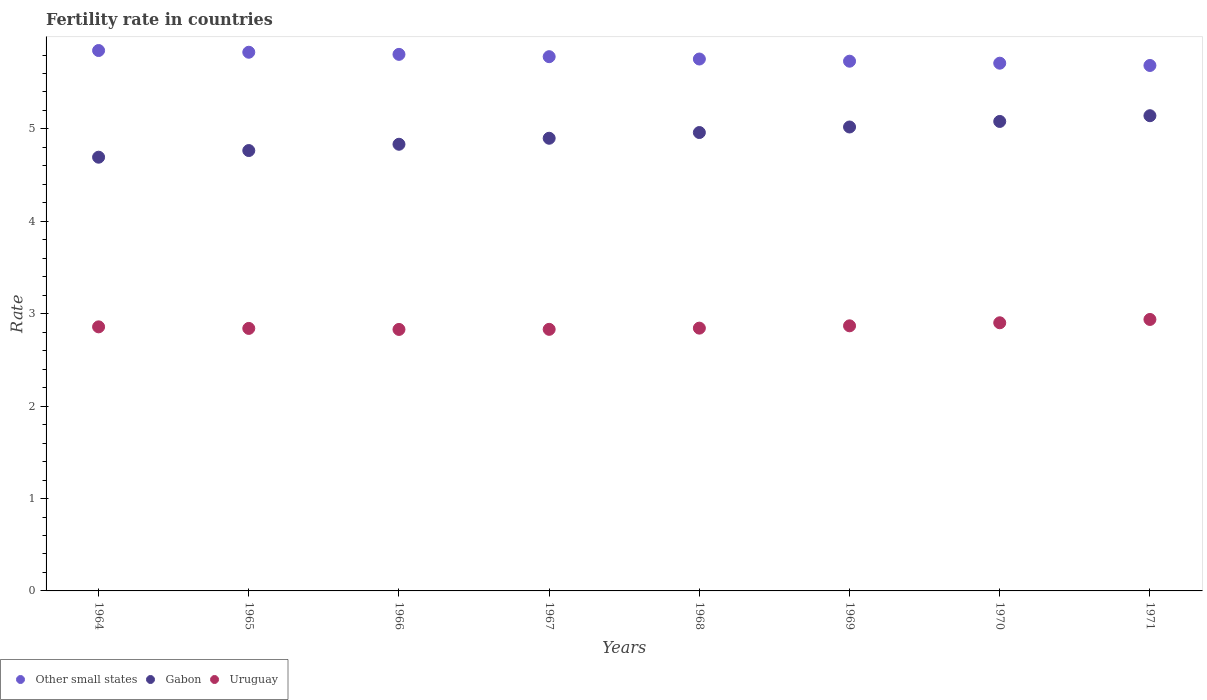What is the fertility rate in Other small states in 1964?
Keep it short and to the point. 5.85. Across all years, what is the maximum fertility rate in Gabon?
Offer a terse response. 5.14. Across all years, what is the minimum fertility rate in Gabon?
Your answer should be compact. 4.69. In which year was the fertility rate in Gabon minimum?
Your response must be concise. 1964. What is the total fertility rate in Gabon in the graph?
Offer a terse response. 39.4. What is the difference between the fertility rate in Uruguay in 1966 and that in 1971?
Keep it short and to the point. -0.11. What is the difference between the fertility rate in Uruguay in 1969 and the fertility rate in Gabon in 1965?
Your answer should be very brief. -1.9. What is the average fertility rate in Other small states per year?
Give a very brief answer. 5.77. In the year 1970, what is the difference between the fertility rate in Uruguay and fertility rate in Other small states?
Make the answer very short. -2.81. In how many years, is the fertility rate in Other small states greater than 4.2?
Your answer should be compact. 8. What is the ratio of the fertility rate in Gabon in 1968 to that in 1970?
Your response must be concise. 0.98. Is the fertility rate in Uruguay in 1964 less than that in 1965?
Give a very brief answer. No. Is the difference between the fertility rate in Uruguay in 1967 and 1969 greater than the difference between the fertility rate in Other small states in 1967 and 1969?
Your answer should be compact. No. What is the difference between the highest and the second highest fertility rate in Other small states?
Your response must be concise. 0.02. What is the difference between the highest and the lowest fertility rate in Gabon?
Offer a terse response. 0.45. Is it the case that in every year, the sum of the fertility rate in Gabon and fertility rate in Uruguay  is greater than the fertility rate in Other small states?
Keep it short and to the point. Yes. Does the fertility rate in Other small states monotonically increase over the years?
Keep it short and to the point. No. Is the fertility rate in Uruguay strictly greater than the fertility rate in Other small states over the years?
Give a very brief answer. No. Is the fertility rate in Other small states strictly less than the fertility rate in Uruguay over the years?
Provide a short and direct response. No. How many years are there in the graph?
Give a very brief answer. 8. Does the graph contain any zero values?
Your answer should be very brief. No. Does the graph contain grids?
Offer a very short reply. No. What is the title of the graph?
Provide a succinct answer. Fertility rate in countries. What is the label or title of the X-axis?
Your answer should be very brief. Years. What is the label or title of the Y-axis?
Your response must be concise. Rate. What is the Rate in Other small states in 1964?
Keep it short and to the point. 5.85. What is the Rate in Gabon in 1964?
Provide a short and direct response. 4.69. What is the Rate in Uruguay in 1964?
Keep it short and to the point. 2.86. What is the Rate of Other small states in 1965?
Provide a succinct answer. 5.83. What is the Rate of Gabon in 1965?
Your response must be concise. 4.77. What is the Rate in Uruguay in 1965?
Keep it short and to the point. 2.84. What is the Rate in Other small states in 1966?
Your answer should be very brief. 5.81. What is the Rate of Gabon in 1966?
Your answer should be compact. 4.83. What is the Rate in Uruguay in 1966?
Provide a short and direct response. 2.83. What is the Rate in Other small states in 1967?
Provide a short and direct response. 5.78. What is the Rate in Gabon in 1967?
Provide a succinct answer. 4.9. What is the Rate of Uruguay in 1967?
Your answer should be very brief. 2.83. What is the Rate in Other small states in 1968?
Provide a short and direct response. 5.76. What is the Rate of Gabon in 1968?
Your answer should be very brief. 4.96. What is the Rate of Uruguay in 1968?
Keep it short and to the point. 2.84. What is the Rate of Other small states in 1969?
Your answer should be compact. 5.73. What is the Rate in Gabon in 1969?
Ensure brevity in your answer.  5.02. What is the Rate of Uruguay in 1969?
Ensure brevity in your answer.  2.87. What is the Rate in Other small states in 1970?
Keep it short and to the point. 5.71. What is the Rate of Gabon in 1970?
Make the answer very short. 5.08. What is the Rate of Uruguay in 1970?
Offer a terse response. 2.9. What is the Rate in Other small states in 1971?
Offer a terse response. 5.69. What is the Rate in Gabon in 1971?
Offer a terse response. 5.14. What is the Rate in Uruguay in 1971?
Provide a short and direct response. 2.94. Across all years, what is the maximum Rate in Other small states?
Provide a succinct answer. 5.85. Across all years, what is the maximum Rate of Gabon?
Offer a terse response. 5.14. Across all years, what is the maximum Rate in Uruguay?
Provide a short and direct response. 2.94. Across all years, what is the minimum Rate of Other small states?
Offer a terse response. 5.69. Across all years, what is the minimum Rate in Gabon?
Your response must be concise. 4.69. Across all years, what is the minimum Rate in Uruguay?
Your answer should be compact. 2.83. What is the total Rate in Other small states in the graph?
Provide a succinct answer. 46.16. What is the total Rate of Gabon in the graph?
Offer a terse response. 39.4. What is the total Rate in Uruguay in the graph?
Your answer should be very brief. 22.91. What is the difference between the Rate of Other small states in 1964 and that in 1965?
Give a very brief answer. 0.02. What is the difference between the Rate in Gabon in 1964 and that in 1965?
Offer a terse response. -0.07. What is the difference between the Rate of Uruguay in 1964 and that in 1965?
Your response must be concise. 0.02. What is the difference between the Rate in Other small states in 1964 and that in 1966?
Provide a succinct answer. 0.04. What is the difference between the Rate of Gabon in 1964 and that in 1966?
Make the answer very short. -0.14. What is the difference between the Rate in Uruguay in 1964 and that in 1966?
Your answer should be very brief. 0.03. What is the difference between the Rate of Other small states in 1964 and that in 1967?
Provide a short and direct response. 0.07. What is the difference between the Rate in Gabon in 1964 and that in 1967?
Keep it short and to the point. -0.2. What is the difference between the Rate of Uruguay in 1964 and that in 1967?
Offer a very short reply. 0.03. What is the difference between the Rate in Other small states in 1964 and that in 1968?
Your answer should be very brief. 0.09. What is the difference between the Rate in Gabon in 1964 and that in 1968?
Keep it short and to the point. -0.27. What is the difference between the Rate in Uruguay in 1964 and that in 1968?
Your response must be concise. 0.01. What is the difference between the Rate of Other small states in 1964 and that in 1969?
Your response must be concise. 0.12. What is the difference between the Rate in Gabon in 1964 and that in 1969?
Keep it short and to the point. -0.33. What is the difference between the Rate in Uruguay in 1964 and that in 1969?
Ensure brevity in your answer.  -0.01. What is the difference between the Rate in Other small states in 1964 and that in 1970?
Offer a terse response. 0.14. What is the difference between the Rate of Gabon in 1964 and that in 1970?
Your answer should be compact. -0.39. What is the difference between the Rate in Uruguay in 1964 and that in 1970?
Your response must be concise. -0.04. What is the difference between the Rate in Other small states in 1964 and that in 1971?
Offer a terse response. 0.16. What is the difference between the Rate in Gabon in 1964 and that in 1971?
Keep it short and to the point. -0.45. What is the difference between the Rate of Uruguay in 1964 and that in 1971?
Make the answer very short. -0.08. What is the difference between the Rate of Other small states in 1965 and that in 1966?
Your answer should be compact. 0.02. What is the difference between the Rate of Gabon in 1965 and that in 1966?
Give a very brief answer. -0.07. What is the difference between the Rate in Uruguay in 1965 and that in 1966?
Offer a very short reply. 0.01. What is the difference between the Rate in Other small states in 1965 and that in 1967?
Provide a short and direct response. 0.05. What is the difference between the Rate of Gabon in 1965 and that in 1967?
Offer a terse response. -0.13. What is the difference between the Rate in Uruguay in 1965 and that in 1967?
Offer a terse response. 0.01. What is the difference between the Rate of Other small states in 1965 and that in 1968?
Offer a terse response. 0.07. What is the difference between the Rate in Gabon in 1965 and that in 1968?
Offer a terse response. -0.2. What is the difference between the Rate in Uruguay in 1965 and that in 1968?
Provide a succinct answer. -0. What is the difference between the Rate of Other small states in 1965 and that in 1969?
Provide a succinct answer. 0.1. What is the difference between the Rate of Gabon in 1965 and that in 1969?
Offer a very short reply. -0.26. What is the difference between the Rate in Uruguay in 1965 and that in 1969?
Give a very brief answer. -0.03. What is the difference between the Rate in Other small states in 1965 and that in 1970?
Provide a short and direct response. 0.12. What is the difference between the Rate of Gabon in 1965 and that in 1970?
Your response must be concise. -0.32. What is the difference between the Rate of Uruguay in 1965 and that in 1970?
Your answer should be very brief. -0.06. What is the difference between the Rate in Other small states in 1965 and that in 1971?
Your answer should be compact. 0.14. What is the difference between the Rate in Gabon in 1965 and that in 1971?
Your response must be concise. -0.38. What is the difference between the Rate of Uruguay in 1965 and that in 1971?
Offer a terse response. -0.1. What is the difference between the Rate in Other small states in 1966 and that in 1967?
Make the answer very short. 0.03. What is the difference between the Rate in Gabon in 1966 and that in 1967?
Offer a terse response. -0.07. What is the difference between the Rate in Uruguay in 1966 and that in 1967?
Offer a terse response. -0. What is the difference between the Rate in Other small states in 1966 and that in 1968?
Provide a succinct answer. 0.05. What is the difference between the Rate of Gabon in 1966 and that in 1968?
Make the answer very short. -0.13. What is the difference between the Rate in Uruguay in 1966 and that in 1968?
Provide a succinct answer. -0.01. What is the difference between the Rate in Other small states in 1966 and that in 1969?
Give a very brief answer. 0.07. What is the difference between the Rate in Gabon in 1966 and that in 1969?
Your answer should be compact. -0.19. What is the difference between the Rate in Uruguay in 1966 and that in 1969?
Your answer should be very brief. -0.04. What is the difference between the Rate in Other small states in 1966 and that in 1970?
Your answer should be very brief. 0.1. What is the difference between the Rate of Gabon in 1966 and that in 1970?
Ensure brevity in your answer.  -0.25. What is the difference between the Rate in Uruguay in 1966 and that in 1970?
Provide a short and direct response. -0.07. What is the difference between the Rate in Other small states in 1966 and that in 1971?
Provide a short and direct response. 0.12. What is the difference between the Rate in Gabon in 1966 and that in 1971?
Your answer should be very brief. -0.31. What is the difference between the Rate in Uruguay in 1966 and that in 1971?
Give a very brief answer. -0.11. What is the difference between the Rate in Other small states in 1967 and that in 1968?
Offer a very short reply. 0.03. What is the difference between the Rate in Gabon in 1967 and that in 1968?
Offer a very short reply. -0.06. What is the difference between the Rate in Uruguay in 1967 and that in 1968?
Give a very brief answer. -0.01. What is the difference between the Rate in Other small states in 1967 and that in 1969?
Provide a succinct answer. 0.05. What is the difference between the Rate of Gabon in 1967 and that in 1969?
Offer a very short reply. -0.12. What is the difference between the Rate of Uruguay in 1967 and that in 1969?
Provide a succinct answer. -0.04. What is the difference between the Rate of Other small states in 1967 and that in 1970?
Your answer should be very brief. 0.07. What is the difference between the Rate in Gabon in 1967 and that in 1970?
Give a very brief answer. -0.18. What is the difference between the Rate in Uruguay in 1967 and that in 1970?
Keep it short and to the point. -0.07. What is the difference between the Rate of Other small states in 1967 and that in 1971?
Your answer should be very brief. 0.1. What is the difference between the Rate in Gabon in 1967 and that in 1971?
Provide a short and direct response. -0.24. What is the difference between the Rate of Uruguay in 1967 and that in 1971?
Provide a succinct answer. -0.11. What is the difference between the Rate of Other small states in 1968 and that in 1969?
Your answer should be compact. 0.02. What is the difference between the Rate in Gabon in 1968 and that in 1969?
Offer a terse response. -0.06. What is the difference between the Rate of Uruguay in 1968 and that in 1969?
Provide a short and direct response. -0.03. What is the difference between the Rate of Other small states in 1968 and that in 1970?
Your response must be concise. 0.05. What is the difference between the Rate of Gabon in 1968 and that in 1970?
Your answer should be very brief. -0.12. What is the difference between the Rate in Uruguay in 1968 and that in 1970?
Offer a terse response. -0.06. What is the difference between the Rate of Other small states in 1968 and that in 1971?
Your answer should be very brief. 0.07. What is the difference between the Rate in Gabon in 1968 and that in 1971?
Your answer should be very brief. -0.18. What is the difference between the Rate of Uruguay in 1968 and that in 1971?
Provide a succinct answer. -0.09. What is the difference between the Rate in Other small states in 1969 and that in 1970?
Your answer should be compact. 0.02. What is the difference between the Rate in Gabon in 1969 and that in 1970?
Offer a terse response. -0.06. What is the difference between the Rate of Uruguay in 1969 and that in 1970?
Provide a succinct answer. -0.03. What is the difference between the Rate of Other small states in 1969 and that in 1971?
Ensure brevity in your answer.  0.05. What is the difference between the Rate of Gabon in 1969 and that in 1971?
Your answer should be very brief. -0.12. What is the difference between the Rate in Uruguay in 1969 and that in 1971?
Your answer should be very brief. -0.07. What is the difference between the Rate in Other small states in 1970 and that in 1971?
Your response must be concise. 0.02. What is the difference between the Rate in Gabon in 1970 and that in 1971?
Your answer should be compact. -0.06. What is the difference between the Rate of Uruguay in 1970 and that in 1971?
Your answer should be very brief. -0.04. What is the difference between the Rate of Other small states in 1964 and the Rate of Gabon in 1965?
Your answer should be compact. 1.08. What is the difference between the Rate of Other small states in 1964 and the Rate of Uruguay in 1965?
Offer a very short reply. 3.01. What is the difference between the Rate of Gabon in 1964 and the Rate of Uruguay in 1965?
Keep it short and to the point. 1.85. What is the difference between the Rate in Other small states in 1964 and the Rate in Gabon in 1966?
Offer a very short reply. 1.01. What is the difference between the Rate in Other small states in 1964 and the Rate in Uruguay in 1966?
Provide a succinct answer. 3.02. What is the difference between the Rate of Gabon in 1964 and the Rate of Uruguay in 1966?
Give a very brief answer. 1.86. What is the difference between the Rate of Other small states in 1964 and the Rate of Gabon in 1967?
Offer a very short reply. 0.95. What is the difference between the Rate of Other small states in 1964 and the Rate of Uruguay in 1967?
Provide a short and direct response. 3.02. What is the difference between the Rate in Gabon in 1964 and the Rate in Uruguay in 1967?
Offer a terse response. 1.86. What is the difference between the Rate of Other small states in 1964 and the Rate of Gabon in 1968?
Offer a terse response. 0.89. What is the difference between the Rate in Other small states in 1964 and the Rate in Uruguay in 1968?
Ensure brevity in your answer.  3. What is the difference between the Rate in Gabon in 1964 and the Rate in Uruguay in 1968?
Ensure brevity in your answer.  1.85. What is the difference between the Rate of Other small states in 1964 and the Rate of Gabon in 1969?
Offer a terse response. 0.83. What is the difference between the Rate in Other small states in 1964 and the Rate in Uruguay in 1969?
Your answer should be very brief. 2.98. What is the difference between the Rate in Gabon in 1964 and the Rate in Uruguay in 1969?
Offer a terse response. 1.82. What is the difference between the Rate in Other small states in 1964 and the Rate in Gabon in 1970?
Provide a succinct answer. 0.77. What is the difference between the Rate of Other small states in 1964 and the Rate of Uruguay in 1970?
Offer a very short reply. 2.95. What is the difference between the Rate in Gabon in 1964 and the Rate in Uruguay in 1970?
Keep it short and to the point. 1.79. What is the difference between the Rate of Other small states in 1964 and the Rate of Gabon in 1971?
Offer a very short reply. 0.71. What is the difference between the Rate of Other small states in 1964 and the Rate of Uruguay in 1971?
Your response must be concise. 2.91. What is the difference between the Rate in Gabon in 1964 and the Rate in Uruguay in 1971?
Provide a succinct answer. 1.76. What is the difference between the Rate of Other small states in 1965 and the Rate of Uruguay in 1966?
Offer a very short reply. 3. What is the difference between the Rate of Gabon in 1965 and the Rate of Uruguay in 1966?
Offer a very short reply. 1.94. What is the difference between the Rate of Other small states in 1965 and the Rate of Gabon in 1967?
Your answer should be very brief. 0.93. What is the difference between the Rate in Other small states in 1965 and the Rate in Uruguay in 1967?
Ensure brevity in your answer.  3. What is the difference between the Rate of Gabon in 1965 and the Rate of Uruguay in 1967?
Make the answer very short. 1.94. What is the difference between the Rate in Other small states in 1965 and the Rate in Gabon in 1968?
Your response must be concise. 0.87. What is the difference between the Rate of Other small states in 1965 and the Rate of Uruguay in 1968?
Offer a very short reply. 2.99. What is the difference between the Rate of Gabon in 1965 and the Rate of Uruguay in 1968?
Keep it short and to the point. 1.92. What is the difference between the Rate in Other small states in 1965 and the Rate in Gabon in 1969?
Provide a short and direct response. 0.81. What is the difference between the Rate in Other small states in 1965 and the Rate in Uruguay in 1969?
Your answer should be compact. 2.96. What is the difference between the Rate of Gabon in 1965 and the Rate of Uruguay in 1969?
Offer a very short reply. 1.9. What is the difference between the Rate of Other small states in 1965 and the Rate of Gabon in 1970?
Provide a succinct answer. 0.75. What is the difference between the Rate in Other small states in 1965 and the Rate in Uruguay in 1970?
Your response must be concise. 2.93. What is the difference between the Rate of Gabon in 1965 and the Rate of Uruguay in 1970?
Provide a short and direct response. 1.86. What is the difference between the Rate of Other small states in 1965 and the Rate of Gabon in 1971?
Your answer should be very brief. 0.69. What is the difference between the Rate of Other small states in 1965 and the Rate of Uruguay in 1971?
Make the answer very short. 2.89. What is the difference between the Rate in Gabon in 1965 and the Rate in Uruguay in 1971?
Make the answer very short. 1.83. What is the difference between the Rate of Other small states in 1966 and the Rate of Gabon in 1967?
Give a very brief answer. 0.91. What is the difference between the Rate in Other small states in 1966 and the Rate in Uruguay in 1967?
Give a very brief answer. 2.98. What is the difference between the Rate in Gabon in 1966 and the Rate in Uruguay in 1967?
Give a very brief answer. 2. What is the difference between the Rate in Other small states in 1966 and the Rate in Gabon in 1968?
Your answer should be compact. 0.85. What is the difference between the Rate of Other small states in 1966 and the Rate of Uruguay in 1968?
Offer a terse response. 2.96. What is the difference between the Rate in Gabon in 1966 and the Rate in Uruguay in 1968?
Your response must be concise. 1.99. What is the difference between the Rate in Other small states in 1966 and the Rate in Gabon in 1969?
Give a very brief answer. 0.79. What is the difference between the Rate of Other small states in 1966 and the Rate of Uruguay in 1969?
Provide a short and direct response. 2.94. What is the difference between the Rate of Gabon in 1966 and the Rate of Uruguay in 1969?
Provide a succinct answer. 1.97. What is the difference between the Rate of Other small states in 1966 and the Rate of Gabon in 1970?
Offer a terse response. 0.73. What is the difference between the Rate in Other small states in 1966 and the Rate in Uruguay in 1970?
Make the answer very short. 2.9. What is the difference between the Rate in Gabon in 1966 and the Rate in Uruguay in 1970?
Keep it short and to the point. 1.93. What is the difference between the Rate of Other small states in 1966 and the Rate of Gabon in 1971?
Offer a very short reply. 0.66. What is the difference between the Rate in Other small states in 1966 and the Rate in Uruguay in 1971?
Make the answer very short. 2.87. What is the difference between the Rate in Gabon in 1966 and the Rate in Uruguay in 1971?
Provide a succinct answer. 1.9. What is the difference between the Rate of Other small states in 1967 and the Rate of Gabon in 1968?
Your answer should be very brief. 0.82. What is the difference between the Rate of Other small states in 1967 and the Rate of Uruguay in 1968?
Provide a succinct answer. 2.94. What is the difference between the Rate of Gabon in 1967 and the Rate of Uruguay in 1968?
Provide a short and direct response. 2.06. What is the difference between the Rate of Other small states in 1967 and the Rate of Gabon in 1969?
Ensure brevity in your answer.  0.76. What is the difference between the Rate of Other small states in 1967 and the Rate of Uruguay in 1969?
Provide a succinct answer. 2.91. What is the difference between the Rate of Gabon in 1967 and the Rate of Uruguay in 1969?
Your answer should be very brief. 2.03. What is the difference between the Rate of Other small states in 1967 and the Rate of Gabon in 1970?
Keep it short and to the point. 0.7. What is the difference between the Rate in Other small states in 1967 and the Rate in Uruguay in 1970?
Keep it short and to the point. 2.88. What is the difference between the Rate of Gabon in 1967 and the Rate of Uruguay in 1970?
Your response must be concise. 2. What is the difference between the Rate of Other small states in 1967 and the Rate of Gabon in 1971?
Provide a short and direct response. 0.64. What is the difference between the Rate in Other small states in 1967 and the Rate in Uruguay in 1971?
Your response must be concise. 2.84. What is the difference between the Rate of Gabon in 1967 and the Rate of Uruguay in 1971?
Your answer should be very brief. 1.96. What is the difference between the Rate in Other small states in 1968 and the Rate in Gabon in 1969?
Your response must be concise. 0.74. What is the difference between the Rate in Other small states in 1968 and the Rate in Uruguay in 1969?
Your answer should be compact. 2.89. What is the difference between the Rate in Gabon in 1968 and the Rate in Uruguay in 1969?
Provide a succinct answer. 2.09. What is the difference between the Rate of Other small states in 1968 and the Rate of Gabon in 1970?
Offer a terse response. 0.68. What is the difference between the Rate of Other small states in 1968 and the Rate of Uruguay in 1970?
Provide a short and direct response. 2.85. What is the difference between the Rate in Gabon in 1968 and the Rate in Uruguay in 1970?
Make the answer very short. 2.06. What is the difference between the Rate in Other small states in 1968 and the Rate in Gabon in 1971?
Provide a short and direct response. 0.61. What is the difference between the Rate in Other small states in 1968 and the Rate in Uruguay in 1971?
Ensure brevity in your answer.  2.82. What is the difference between the Rate in Gabon in 1968 and the Rate in Uruguay in 1971?
Provide a short and direct response. 2.02. What is the difference between the Rate of Other small states in 1969 and the Rate of Gabon in 1970?
Your answer should be very brief. 0.65. What is the difference between the Rate of Other small states in 1969 and the Rate of Uruguay in 1970?
Offer a very short reply. 2.83. What is the difference between the Rate of Gabon in 1969 and the Rate of Uruguay in 1970?
Your answer should be very brief. 2.12. What is the difference between the Rate in Other small states in 1969 and the Rate in Gabon in 1971?
Offer a terse response. 0.59. What is the difference between the Rate in Other small states in 1969 and the Rate in Uruguay in 1971?
Your response must be concise. 2.79. What is the difference between the Rate of Gabon in 1969 and the Rate of Uruguay in 1971?
Your answer should be compact. 2.08. What is the difference between the Rate of Other small states in 1970 and the Rate of Gabon in 1971?
Your answer should be compact. 0.57. What is the difference between the Rate of Other small states in 1970 and the Rate of Uruguay in 1971?
Your answer should be compact. 2.77. What is the difference between the Rate of Gabon in 1970 and the Rate of Uruguay in 1971?
Offer a very short reply. 2.14. What is the average Rate in Other small states per year?
Your response must be concise. 5.77. What is the average Rate in Gabon per year?
Give a very brief answer. 4.92. What is the average Rate in Uruguay per year?
Provide a short and direct response. 2.86. In the year 1964, what is the difference between the Rate in Other small states and Rate in Gabon?
Provide a succinct answer. 1.15. In the year 1964, what is the difference between the Rate in Other small states and Rate in Uruguay?
Ensure brevity in your answer.  2.99. In the year 1964, what is the difference between the Rate in Gabon and Rate in Uruguay?
Offer a terse response. 1.84. In the year 1965, what is the difference between the Rate in Other small states and Rate in Gabon?
Your answer should be compact. 1.06. In the year 1965, what is the difference between the Rate of Other small states and Rate of Uruguay?
Your response must be concise. 2.99. In the year 1965, what is the difference between the Rate in Gabon and Rate in Uruguay?
Offer a very short reply. 1.93. In the year 1966, what is the difference between the Rate of Other small states and Rate of Gabon?
Your answer should be very brief. 0.97. In the year 1966, what is the difference between the Rate in Other small states and Rate in Uruguay?
Offer a very short reply. 2.98. In the year 1966, what is the difference between the Rate of Gabon and Rate of Uruguay?
Your answer should be very brief. 2. In the year 1967, what is the difference between the Rate of Other small states and Rate of Gabon?
Your answer should be compact. 0.88. In the year 1967, what is the difference between the Rate of Other small states and Rate of Uruguay?
Offer a terse response. 2.95. In the year 1967, what is the difference between the Rate in Gabon and Rate in Uruguay?
Provide a succinct answer. 2.07. In the year 1968, what is the difference between the Rate of Other small states and Rate of Gabon?
Provide a succinct answer. 0.8. In the year 1968, what is the difference between the Rate of Other small states and Rate of Uruguay?
Offer a terse response. 2.91. In the year 1968, what is the difference between the Rate of Gabon and Rate of Uruguay?
Offer a terse response. 2.12. In the year 1969, what is the difference between the Rate of Other small states and Rate of Gabon?
Offer a terse response. 0.71. In the year 1969, what is the difference between the Rate in Other small states and Rate in Uruguay?
Your response must be concise. 2.86. In the year 1969, what is the difference between the Rate of Gabon and Rate of Uruguay?
Give a very brief answer. 2.15. In the year 1970, what is the difference between the Rate of Other small states and Rate of Gabon?
Offer a very short reply. 0.63. In the year 1970, what is the difference between the Rate of Other small states and Rate of Uruguay?
Offer a terse response. 2.81. In the year 1970, what is the difference between the Rate of Gabon and Rate of Uruguay?
Keep it short and to the point. 2.18. In the year 1971, what is the difference between the Rate of Other small states and Rate of Gabon?
Keep it short and to the point. 0.54. In the year 1971, what is the difference between the Rate in Other small states and Rate in Uruguay?
Provide a succinct answer. 2.75. In the year 1971, what is the difference between the Rate of Gabon and Rate of Uruguay?
Ensure brevity in your answer.  2.21. What is the ratio of the Rate in Gabon in 1964 to that in 1965?
Your answer should be compact. 0.98. What is the ratio of the Rate in Uruguay in 1964 to that in 1966?
Provide a succinct answer. 1.01. What is the ratio of the Rate in Other small states in 1964 to that in 1967?
Your answer should be very brief. 1.01. What is the ratio of the Rate of Gabon in 1964 to that in 1967?
Your response must be concise. 0.96. What is the ratio of the Rate in Uruguay in 1964 to that in 1967?
Keep it short and to the point. 1.01. What is the ratio of the Rate in Gabon in 1964 to that in 1968?
Your answer should be compact. 0.95. What is the ratio of the Rate in Other small states in 1964 to that in 1969?
Your answer should be compact. 1.02. What is the ratio of the Rate in Gabon in 1964 to that in 1969?
Ensure brevity in your answer.  0.93. What is the ratio of the Rate of Uruguay in 1964 to that in 1969?
Offer a terse response. 1. What is the ratio of the Rate of Gabon in 1964 to that in 1970?
Offer a terse response. 0.92. What is the ratio of the Rate of Other small states in 1964 to that in 1971?
Your answer should be very brief. 1.03. What is the ratio of the Rate of Gabon in 1964 to that in 1971?
Offer a terse response. 0.91. What is the ratio of the Rate in Uruguay in 1964 to that in 1971?
Offer a very short reply. 0.97. What is the ratio of the Rate of Gabon in 1965 to that in 1966?
Offer a very short reply. 0.99. What is the ratio of the Rate in Uruguay in 1965 to that in 1966?
Offer a very short reply. 1. What is the ratio of the Rate of Other small states in 1965 to that in 1967?
Provide a succinct answer. 1.01. What is the ratio of the Rate of Gabon in 1965 to that in 1967?
Offer a very short reply. 0.97. What is the ratio of the Rate of Uruguay in 1965 to that in 1967?
Provide a short and direct response. 1. What is the ratio of the Rate of Other small states in 1965 to that in 1968?
Keep it short and to the point. 1.01. What is the ratio of the Rate in Gabon in 1965 to that in 1968?
Give a very brief answer. 0.96. What is the ratio of the Rate in Uruguay in 1965 to that in 1968?
Your answer should be compact. 1. What is the ratio of the Rate in Other small states in 1965 to that in 1969?
Provide a short and direct response. 1.02. What is the ratio of the Rate in Gabon in 1965 to that in 1969?
Provide a succinct answer. 0.95. What is the ratio of the Rate in Uruguay in 1965 to that in 1969?
Your answer should be very brief. 0.99. What is the ratio of the Rate in Other small states in 1965 to that in 1970?
Your answer should be very brief. 1.02. What is the ratio of the Rate of Gabon in 1965 to that in 1970?
Your answer should be compact. 0.94. What is the ratio of the Rate of Other small states in 1965 to that in 1971?
Your response must be concise. 1.03. What is the ratio of the Rate in Gabon in 1965 to that in 1971?
Make the answer very short. 0.93. What is the ratio of the Rate in Uruguay in 1965 to that in 1971?
Make the answer very short. 0.97. What is the ratio of the Rate of Other small states in 1966 to that in 1967?
Make the answer very short. 1. What is the ratio of the Rate of Gabon in 1966 to that in 1967?
Offer a very short reply. 0.99. What is the ratio of the Rate of Other small states in 1966 to that in 1968?
Keep it short and to the point. 1.01. What is the ratio of the Rate in Gabon in 1966 to that in 1968?
Keep it short and to the point. 0.97. What is the ratio of the Rate of Uruguay in 1966 to that in 1968?
Keep it short and to the point. 1. What is the ratio of the Rate in Other small states in 1966 to that in 1969?
Keep it short and to the point. 1.01. What is the ratio of the Rate in Gabon in 1966 to that in 1969?
Keep it short and to the point. 0.96. What is the ratio of the Rate of Uruguay in 1966 to that in 1969?
Your answer should be very brief. 0.99. What is the ratio of the Rate in Other small states in 1966 to that in 1970?
Provide a succinct answer. 1.02. What is the ratio of the Rate in Gabon in 1966 to that in 1970?
Provide a short and direct response. 0.95. What is the ratio of the Rate in Uruguay in 1966 to that in 1970?
Your answer should be very brief. 0.98. What is the ratio of the Rate of Other small states in 1966 to that in 1971?
Make the answer very short. 1.02. What is the ratio of the Rate in Gabon in 1966 to that in 1971?
Ensure brevity in your answer.  0.94. What is the ratio of the Rate in Uruguay in 1966 to that in 1971?
Give a very brief answer. 0.96. What is the ratio of the Rate in Gabon in 1967 to that in 1968?
Give a very brief answer. 0.99. What is the ratio of the Rate of Other small states in 1967 to that in 1969?
Offer a terse response. 1.01. What is the ratio of the Rate in Gabon in 1967 to that in 1969?
Your answer should be compact. 0.98. What is the ratio of the Rate in Other small states in 1967 to that in 1970?
Keep it short and to the point. 1.01. What is the ratio of the Rate of Gabon in 1967 to that in 1970?
Your answer should be compact. 0.96. What is the ratio of the Rate of Uruguay in 1967 to that in 1970?
Offer a terse response. 0.98. What is the ratio of the Rate in Other small states in 1967 to that in 1971?
Ensure brevity in your answer.  1.02. What is the ratio of the Rate in Gabon in 1967 to that in 1971?
Give a very brief answer. 0.95. What is the ratio of the Rate of Uruguay in 1967 to that in 1971?
Keep it short and to the point. 0.96. What is the ratio of the Rate in Gabon in 1968 to that in 1969?
Offer a terse response. 0.99. What is the ratio of the Rate in Uruguay in 1968 to that in 1969?
Your response must be concise. 0.99. What is the ratio of the Rate in Other small states in 1968 to that in 1970?
Make the answer very short. 1.01. What is the ratio of the Rate of Gabon in 1968 to that in 1970?
Keep it short and to the point. 0.98. What is the ratio of the Rate in Other small states in 1968 to that in 1971?
Give a very brief answer. 1.01. What is the ratio of the Rate in Gabon in 1968 to that in 1971?
Make the answer very short. 0.96. What is the ratio of the Rate in Uruguay in 1968 to that in 1971?
Your answer should be compact. 0.97. What is the ratio of the Rate of Other small states in 1969 to that in 1970?
Your response must be concise. 1. What is the ratio of the Rate in Gabon in 1969 to that in 1970?
Provide a short and direct response. 0.99. What is the ratio of the Rate in Uruguay in 1969 to that in 1970?
Your response must be concise. 0.99. What is the ratio of the Rate in Other small states in 1969 to that in 1971?
Your answer should be compact. 1.01. What is the ratio of the Rate of Gabon in 1969 to that in 1971?
Keep it short and to the point. 0.98. What is the ratio of the Rate of Uruguay in 1969 to that in 1971?
Your answer should be very brief. 0.98. What is the ratio of the Rate of Other small states in 1970 to that in 1971?
Your answer should be very brief. 1. What is the ratio of the Rate in Gabon in 1970 to that in 1971?
Ensure brevity in your answer.  0.99. What is the ratio of the Rate of Uruguay in 1970 to that in 1971?
Give a very brief answer. 0.99. What is the difference between the highest and the second highest Rate of Other small states?
Your answer should be very brief. 0.02. What is the difference between the highest and the second highest Rate in Gabon?
Offer a terse response. 0.06. What is the difference between the highest and the second highest Rate of Uruguay?
Offer a terse response. 0.04. What is the difference between the highest and the lowest Rate in Other small states?
Make the answer very short. 0.16. What is the difference between the highest and the lowest Rate in Gabon?
Make the answer very short. 0.45. What is the difference between the highest and the lowest Rate of Uruguay?
Offer a terse response. 0.11. 